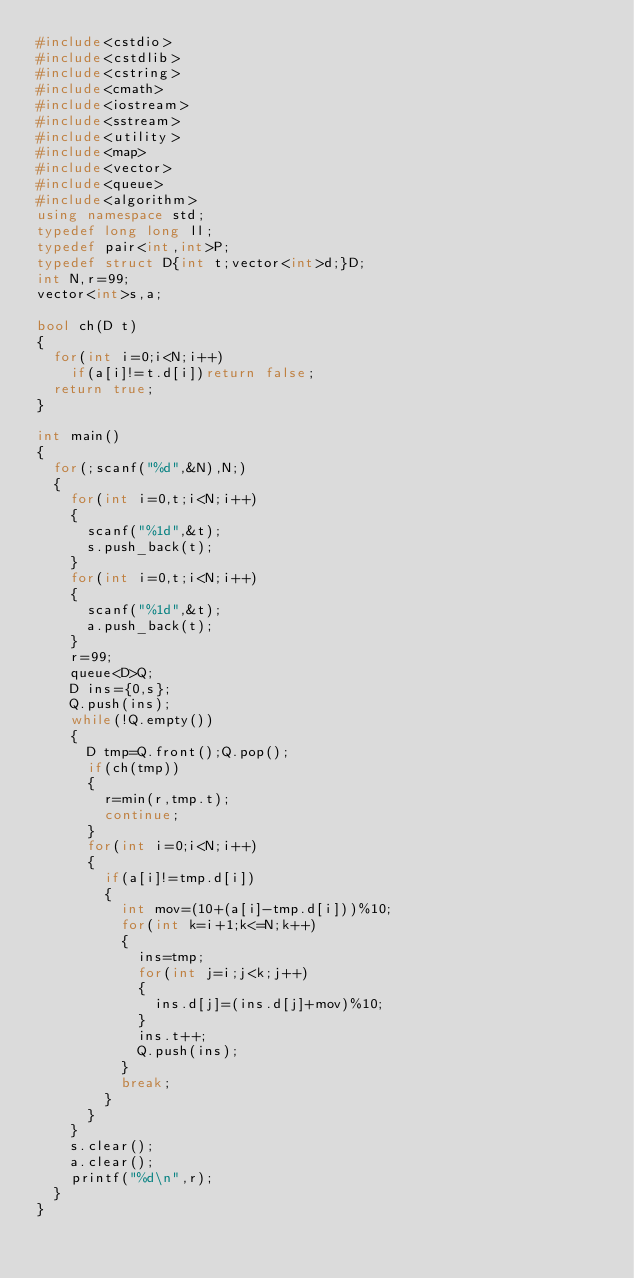Convert code to text. <code><loc_0><loc_0><loc_500><loc_500><_C++_>#include<cstdio>
#include<cstdlib>
#include<cstring>
#include<cmath>
#include<iostream>
#include<sstream>
#include<utility>
#include<map>
#include<vector>
#include<queue>
#include<algorithm>
using namespace std;
typedef long long ll;
typedef pair<int,int>P;
typedef struct D{int t;vector<int>d;}D;
int N,r=99;
vector<int>s,a;

bool ch(D t)
{
	for(int i=0;i<N;i++)
		if(a[i]!=t.d[i])return false;
	return true;
}

int main()
{
	for(;scanf("%d",&N),N;)
	{
		for(int i=0,t;i<N;i++)
		{
			scanf("%1d",&t);
			s.push_back(t);
		}
		for(int i=0,t;i<N;i++)
		{
			scanf("%1d",&t);
			a.push_back(t);
		}
		r=99;
		queue<D>Q;
		D ins={0,s};
		Q.push(ins);
		while(!Q.empty())
		{
			D tmp=Q.front();Q.pop();
			if(ch(tmp))
			{
				r=min(r,tmp.t);
				continue;
			}
			for(int i=0;i<N;i++)
			{
				if(a[i]!=tmp.d[i])
				{
					int mov=(10+(a[i]-tmp.d[i]))%10;
					for(int k=i+1;k<=N;k++)
					{
						ins=tmp;
						for(int j=i;j<k;j++)
						{
							ins.d[j]=(ins.d[j]+mov)%10;
						}
						ins.t++;
						Q.push(ins);
					}
					break;
				}
			}
		}
		s.clear();
		a.clear();
		printf("%d\n",r);
	}
}</code> 